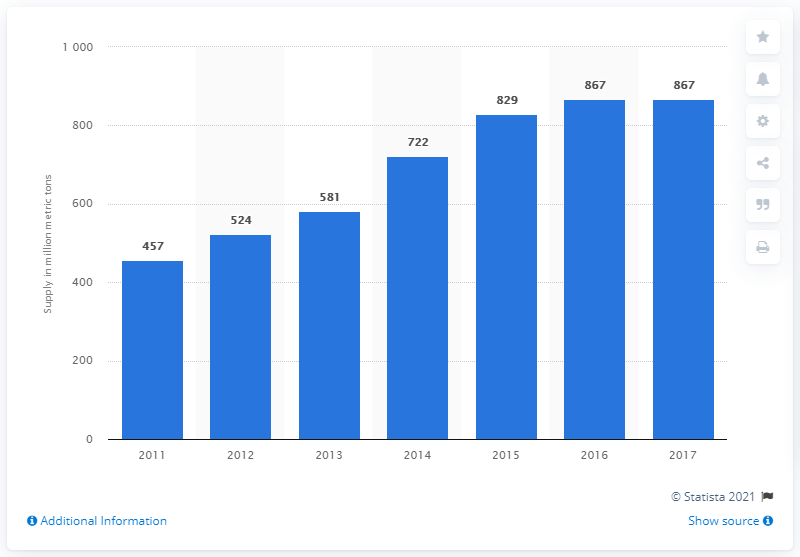Indicate a few pertinent items in this graphic. According to estimates, Australia's seaborne supply of iron ore is expected to reach 829 million metric tons in 2015. 